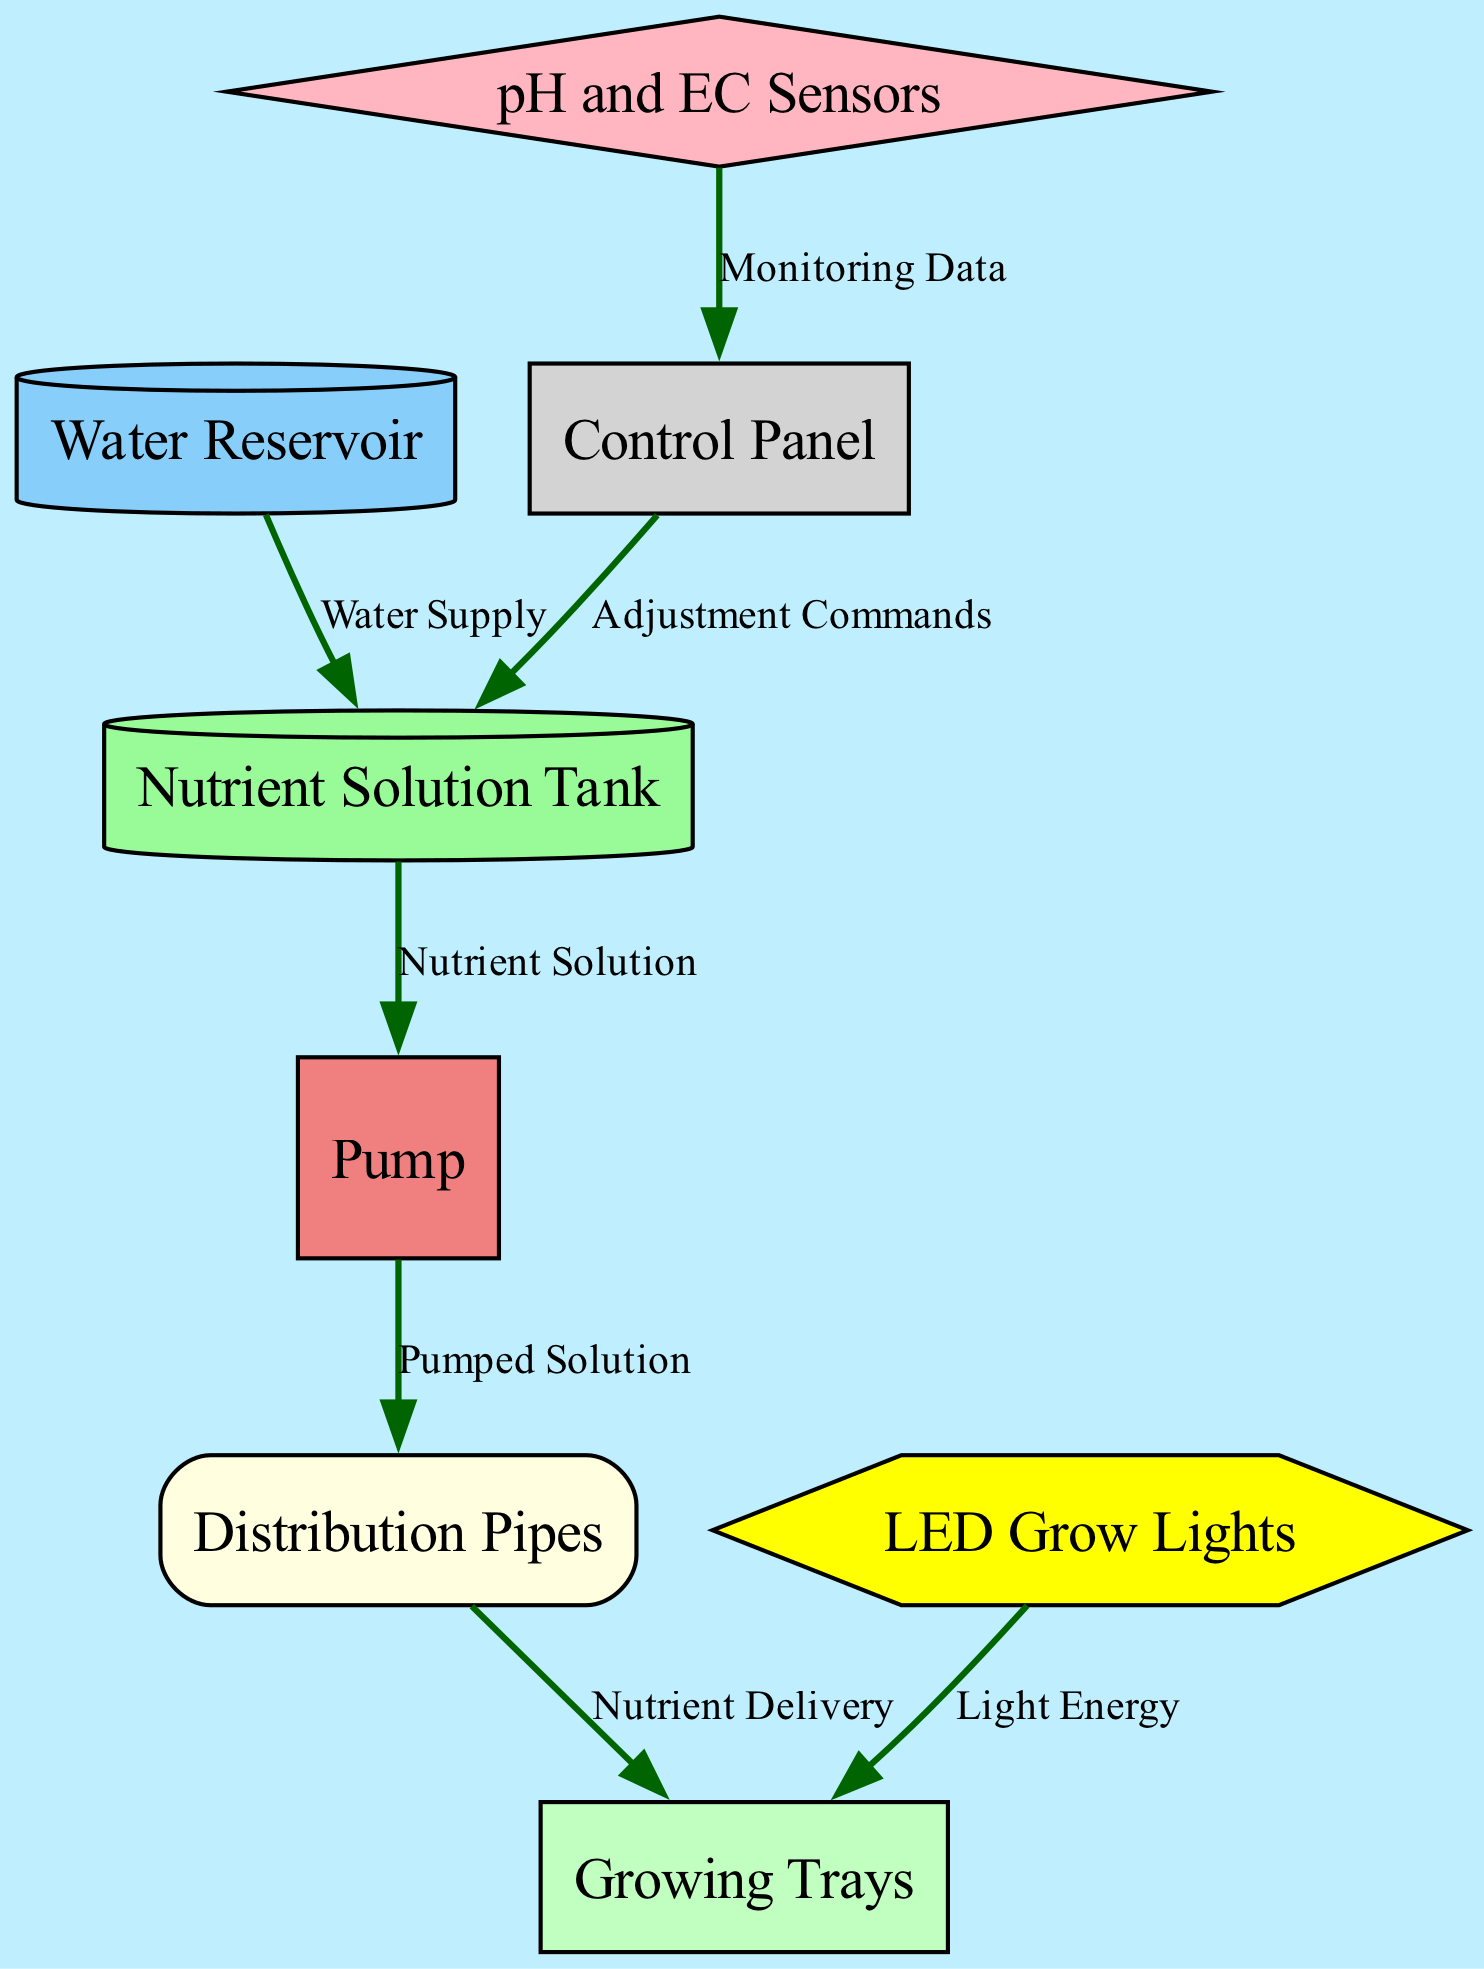What is the first component in the hydroponic system? The first node listed in the diagram is the "Water Reservoir," which serves as the starting component for water supply.
Answer: Water Reservoir How many nodes are in the hydroponic diagram? By counting each unique component (nodes), we find there are a total of 8 nodes listed in the diagram.
Answer: 8 What is transported from the Nutrient Solution Tank to the Pump? The edge labeled "Nutrient Solution" indicates that a nutrient solution is transported from the Nutrient Solution Tank to the Pump.
Answer: Nutrient Solution Which component provides light energy to the Growing Trays? The edge connecting "LED Grow Lights" to "Growing Trays" labeled "Light Energy" indicates that this component provides light energy necessary for growth.
Answer: LED Grow Lights What is the relationship between the pH and EC Sensors and the Control Panel? The diagram shows an edge from "pH and EC Sensors" to "Control Panel" labeled "Monitoring Data," indicating that the sensors provide data to the control system.
Answer: Monitoring Data What is the purpose of the Control Panel in the system? The diagram indicates that the Control Panel receives monitoring data from the Sensors and sends adjustment commands back to the Nutrient Solution Tank, coordinating the system's functions.
Answer: Adjustment Commands How many edges are present in the diagram? By counting the connections (edges) between nodes, we find that there are a total of 6 edges in the hydroponic system diagram.
Answer: 6 In what order does the nutrient solution flow from the Water Reservoir to the Growing Trays? Tracing the path: water flows from the Water Reservoir to the Nutrient Solution Tank, then to the Pump, through Distribution Pipes, and finally delivered to the Growing Trays.
Answer: Water Reservoir → Nutrient Solution Tank → Pump → Distribution Pipes → Growing Trays How does the system monitor the nutrients and pH levels? The diagram shows that the "pH and EC Sensors" continuously monitor the nutrient solution and send this data to the "Control Panel" for adjustments, which is essential for maintaining the system's balance.
Answer: Monitoring Data 